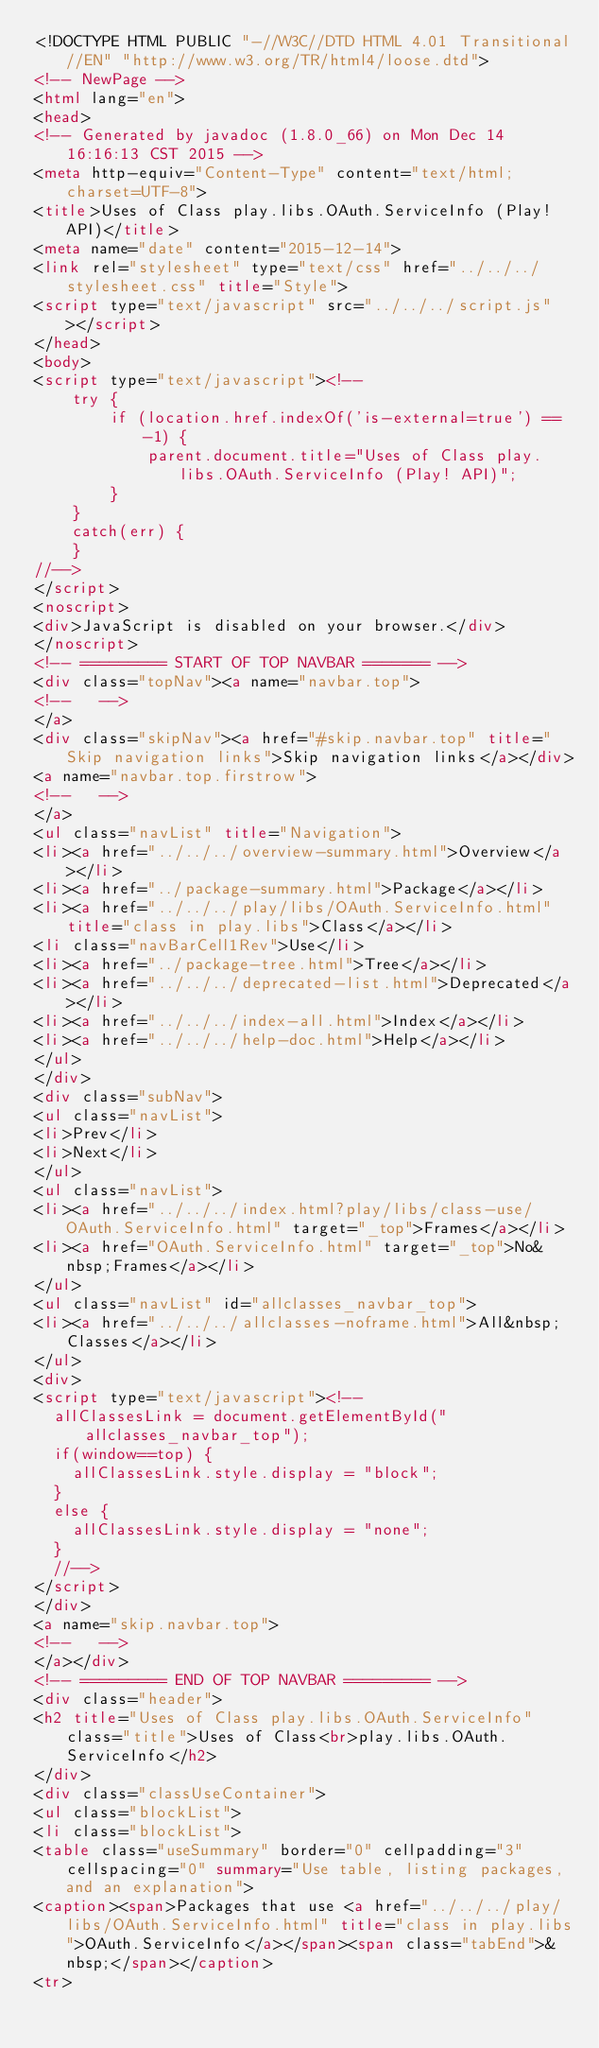<code> <loc_0><loc_0><loc_500><loc_500><_HTML_><!DOCTYPE HTML PUBLIC "-//W3C//DTD HTML 4.01 Transitional//EN" "http://www.w3.org/TR/html4/loose.dtd">
<!-- NewPage -->
<html lang="en">
<head>
<!-- Generated by javadoc (1.8.0_66) on Mon Dec 14 16:16:13 CST 2015 -->
<meta http-equiv="Content-Type" content="text/html; charset=UTF-8">
<title>Uses of Class play.libs.OAuth.ServiceInfo (Play! API)</title>
<meta name="date" content="2015-12-14">
<link rel="stylesheet" type="text/css" href="../../../stylesheet.css" title="Style">
<script type="text/javascript" src="../../../script.js"></script>
</head>
<body>
<script type="text/javascript"><!--
    try {
        if (location.href.indexOf('is-external=true') == -1) {
            parent.document.title="Uses of Class play.libs.OAuth.ServiceInfo (Play! API)";
        }
    }
    catch(err) {
    }
//-->
</script>
<noscript>
<div>JavaScript is disabled on your browser.</div>
</noscript>
<!-- ========= START OF TOP NAVBAR ======= -->
<div class="topNav"><a name="navbar.top">
<!--   -->
</a>
<div class="skipNav"><a href="#skip.navbar.top" title="Skip navigation links">Skip navigation links</a></div>
<a name="navbar.top.firstrow">
<!--   -->
</a>
<ul class="navList" title="Navigation">
<li><a href="../../../overview-summary.html">Overview</a></li>
<li><a href="../package-summary.html">Package</a></li>
<li><a href="../../../play/libs/OAuth.ServiceInfo.html" title="class in play.libs">Class</a></li>
<li class="navBarCell1Rev">Use</li>
<li><a href="../package-tree.html">Tree</a></li>
<li><a href="../../../deprecated-list.html">Deprecated</a></li>
<li><a href="../../../index-all.html">Index</a></li>
<li><a href="../../../help-doc.html">Help</a></li>
</ul>
</div>
<div class="subNav">
<ul class="navList">
<li>Prev</li>
<li>Next</li>
</ul>
<ul class="navList">
<li><a href="../../../index.html?play/libs/class-use/OAuth.ServiceInfo.html" target="_top">Frames</a></li>
<li><a href="OAuth.ServiceInfo.html" target="_top">No&nbsp;Frames</a></li>
</ul>
<ul class="navList" id="allclasses_navbar_top">
<li><a href="../../../allclasses-noframe.html">All&nbsp;Classes</a></li>
</ul>
<div>
<script type="text/javascript"><!--
  allClassesLink = document.getElementById("allclasses_navbar_top");
  if(window==top) {
    allClassesLink.style.display = "block";
  }
  else {
    allClassesLink.style.display = "none";
  }
  //-->
</script>
</div>
<a name="skip.navbar.top">
<!--   -->
</a></div>
<!-- ========= END OF TOP NAVBAR ========= -->
<div class="header">
<h2 title="Uses of Class play.libs.OAuth.ServiceInfo" class="title">Uses of Class<br>play.libs.OAuth.ServiceInfo</h2>
</div>
<div class="classUseContainer">
<ul class="blockList">
<li class="blockList">
<table class="useSummary" border="0" cellpadding="3" cellspacing="0" summary="Use table, listing packages, and an explanation">
<caption><span>Packages that use <a href="../../../play/libs/OAuth.ServiceInfo.html" title="class in play.libs">OAuth.ServiceInfo</a></span><span class="tabEnd">&nbsp;</span></caption>
<tr></code> 